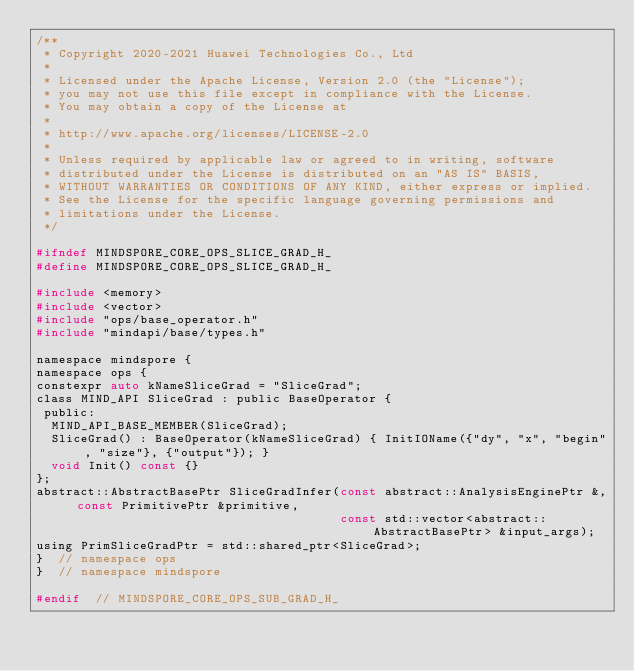Convert code to text. <code><loc_0><loc_0><loc_500><loc_500><_C_>/**
 * Copyright 2020-2021 Huawei Technologies Co., Ltd
 *
 * Licensed under the Apache License, Version 2.0 (the "License");
 * you may not use this file except in compliance with the License.
 * You may obtain a copy of the License at
 *
 * http://www.apache.org/licenses/LICENSE-2.0
 *
 * Unless required by applicable law or agreed to in writing, software
 * distributed under the License is distributed on an "AS IS" BASIS,
 * WITHOUT WARRANTIES OR CONDITIONS OF ANY KIND, either express or implied.
 * See the License for the specific language governing permissions and
 * limitations under the License.
 */

#ifndef MINDSPORE_CORE_OPS_SLICE_GRAD_H_
#define MINDSPORE_CORE_OPS_SLICE_GRAD_H_

#include <memory>
#include <vector>
#include "ops/base_operator.h"
#include "mindapi/base/types.h"

namespace mindspore {
namespace ops {
constexpr auto kNameSliceGrad = "SliceGrad";
class MIND_API SliceGrad : public BaseOperator {
 public:
  MIND_API_BASE_MEMBER(SliceGrad);
  SliceGrad() : BaseOperator(kNameSliceGrad) { InitIOName({"dy", "x", "begin", "size"}, {"output"}); }
  void Init() const {}
};
abstract::AbstractBasePtr SliceGradInfer(const abstract::AnalysisEnginePtr &, const PrimitivePtr &primitive,
                                         const std::vector<abstract::AbstractBasePtr> &input_args);
using PrimSliceGradPtr = std::shared_ptr<SliceGrad>;
}  // namespace ops
}  // namespace mindspore

#endif  // MINDSPORE_CORE_OPS_SUB_GRAD_H_
</code> 